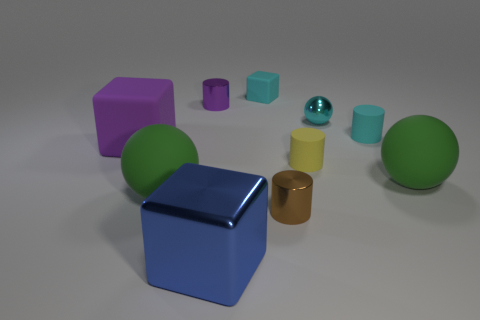What is the material of the tiny cyan block?
Give a very brief answer. Rubber. There is a green matte object that is on the left side of the tiny cyan cube; what size is it?
Your answer should be compact. Large. What number of cyan cubes are in front of the tiny cyan rubber thing right of the small brown metallic object?
Keep it short and to the point. 0. Do the small yellow object behind the metal cube and the big green thing on the left side of the large blue metallic cube have the same shape?
Offer a terse response. No. How many big objects are both in front of the big purple rubber object and on the left side of the small rubber block?
Provide a succinct answer. 2. Is there another tiny shiny block of the same color as the small cube?
Keep it short and to the point. No. The purple matte thing that is the same size as the blue metal thing is what shape?
Give a very brief answer. Cube. There is a large purple object; are there any big purple rubber cubes on the right side of it?
Your response must be concise. No. Is the material of the block on the left side of the large blue shiny block the same as the green ball that is to the right of the brown shiny cylinder?
Your response must be concise. Yes. How many cubes are the same size as the cyan shiny thing?
Offer a terse response. 1. 